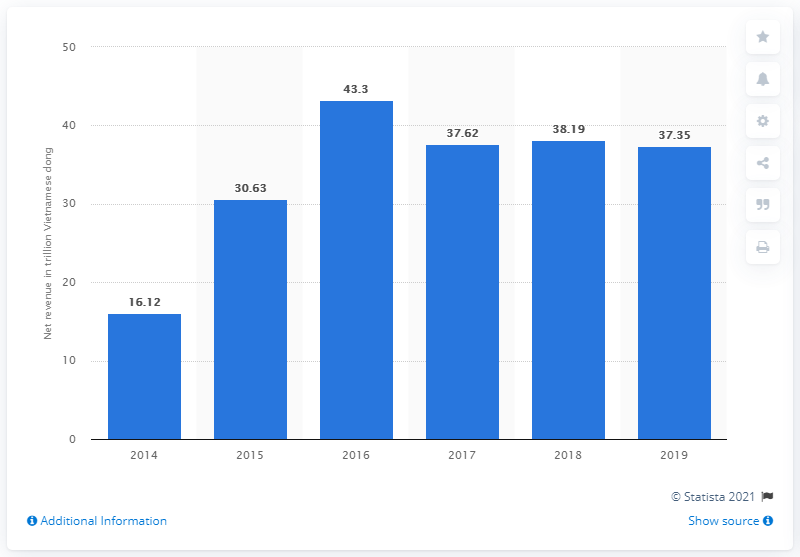Point out several critical features in this image. Masan Group reported a net revenue of 37.35 billion in 2019. 